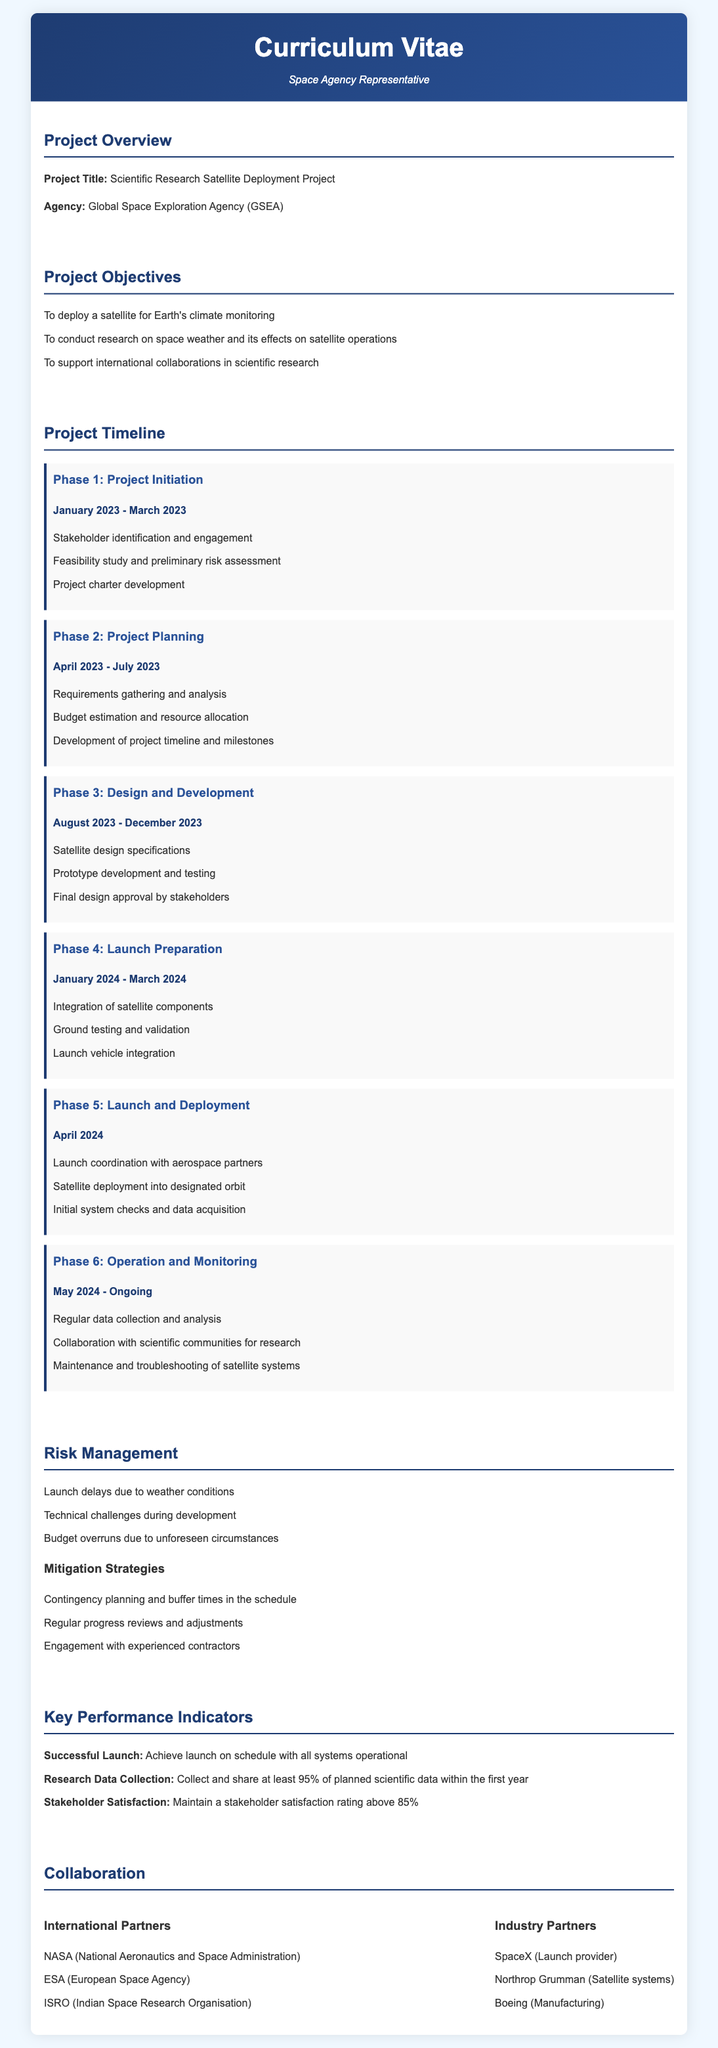what is the project title? The project title is listed in the document as "Scientific Research Satellite Deployment Project."
Answer: Scientific Research Satellite Deployment Project who is the agency behind the project? The agency responsible for the project is mentioned in the document as "Global Space Exploration Agency (GSEA)."
Answer: Global Space Exploration Agency (GSEA) what is the timeline for the design and development phase? The document specifies that the design and development phase runs from August 2023 to December 2023.
Answer: August 2023 - December 2023 what are the key roles of international partners? The document lists various international partners but does not specifically state their roles, requiring reasoning about collaboration and support in satellite deployment.
Answer: Collaboration and support in satellite deployment what is one key performance indicator for research data collection? The document states that a key performance indicator is to collect and share at least 95% of planned scientific data within the first year.
Answer: 95% what is the duration of the launch and deployment phase? The document states that the launch and deployment phase occurs in April 2024, indicating a one-month duration.
Answer: April 2024 which organization is involved as a launch provider? The document mentions "SpaceX" as the launch provider involved in the project.
Answer: SpaceX what is one risk mentioned in the risk management section? The risk management section lists "Launch delays due to weather conditions" as one of the risks.
Answer: Launch delays due to weather conditions 